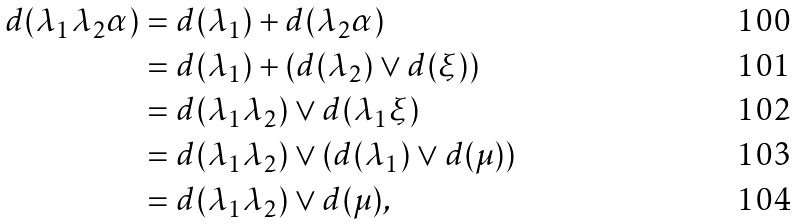Convert formula to latex. <formula><loc_0><loc_0><loc_500><loc_500>d ( \lambda _ { 1 } \lambda _ { 2 } \alpha ) & = d ( \lambda _ { 1 } ) + d ( \lambda _ { 2 } \alpha ) \\ & = d ( \lambda _ { 1 } ) + ( d ( \lambda _ { 2 } ) \vee d ( \xi ) ) \\ & = d ( \lambda _ { 1 } \lambda _ { 2 } ) \vee d ( \lambda _ { 1 } \xi ) \\ & = d ( \lambda _ { 1 } \lambda _ { 2 } ) \vee ( d ( \lambda _ { 1 } ) \vee d ( \mu ) ) \\ & = d ( \lambda _ { 1 } \lambda _ { 2 } ) \vee d ( \mu ) ,</formula> 